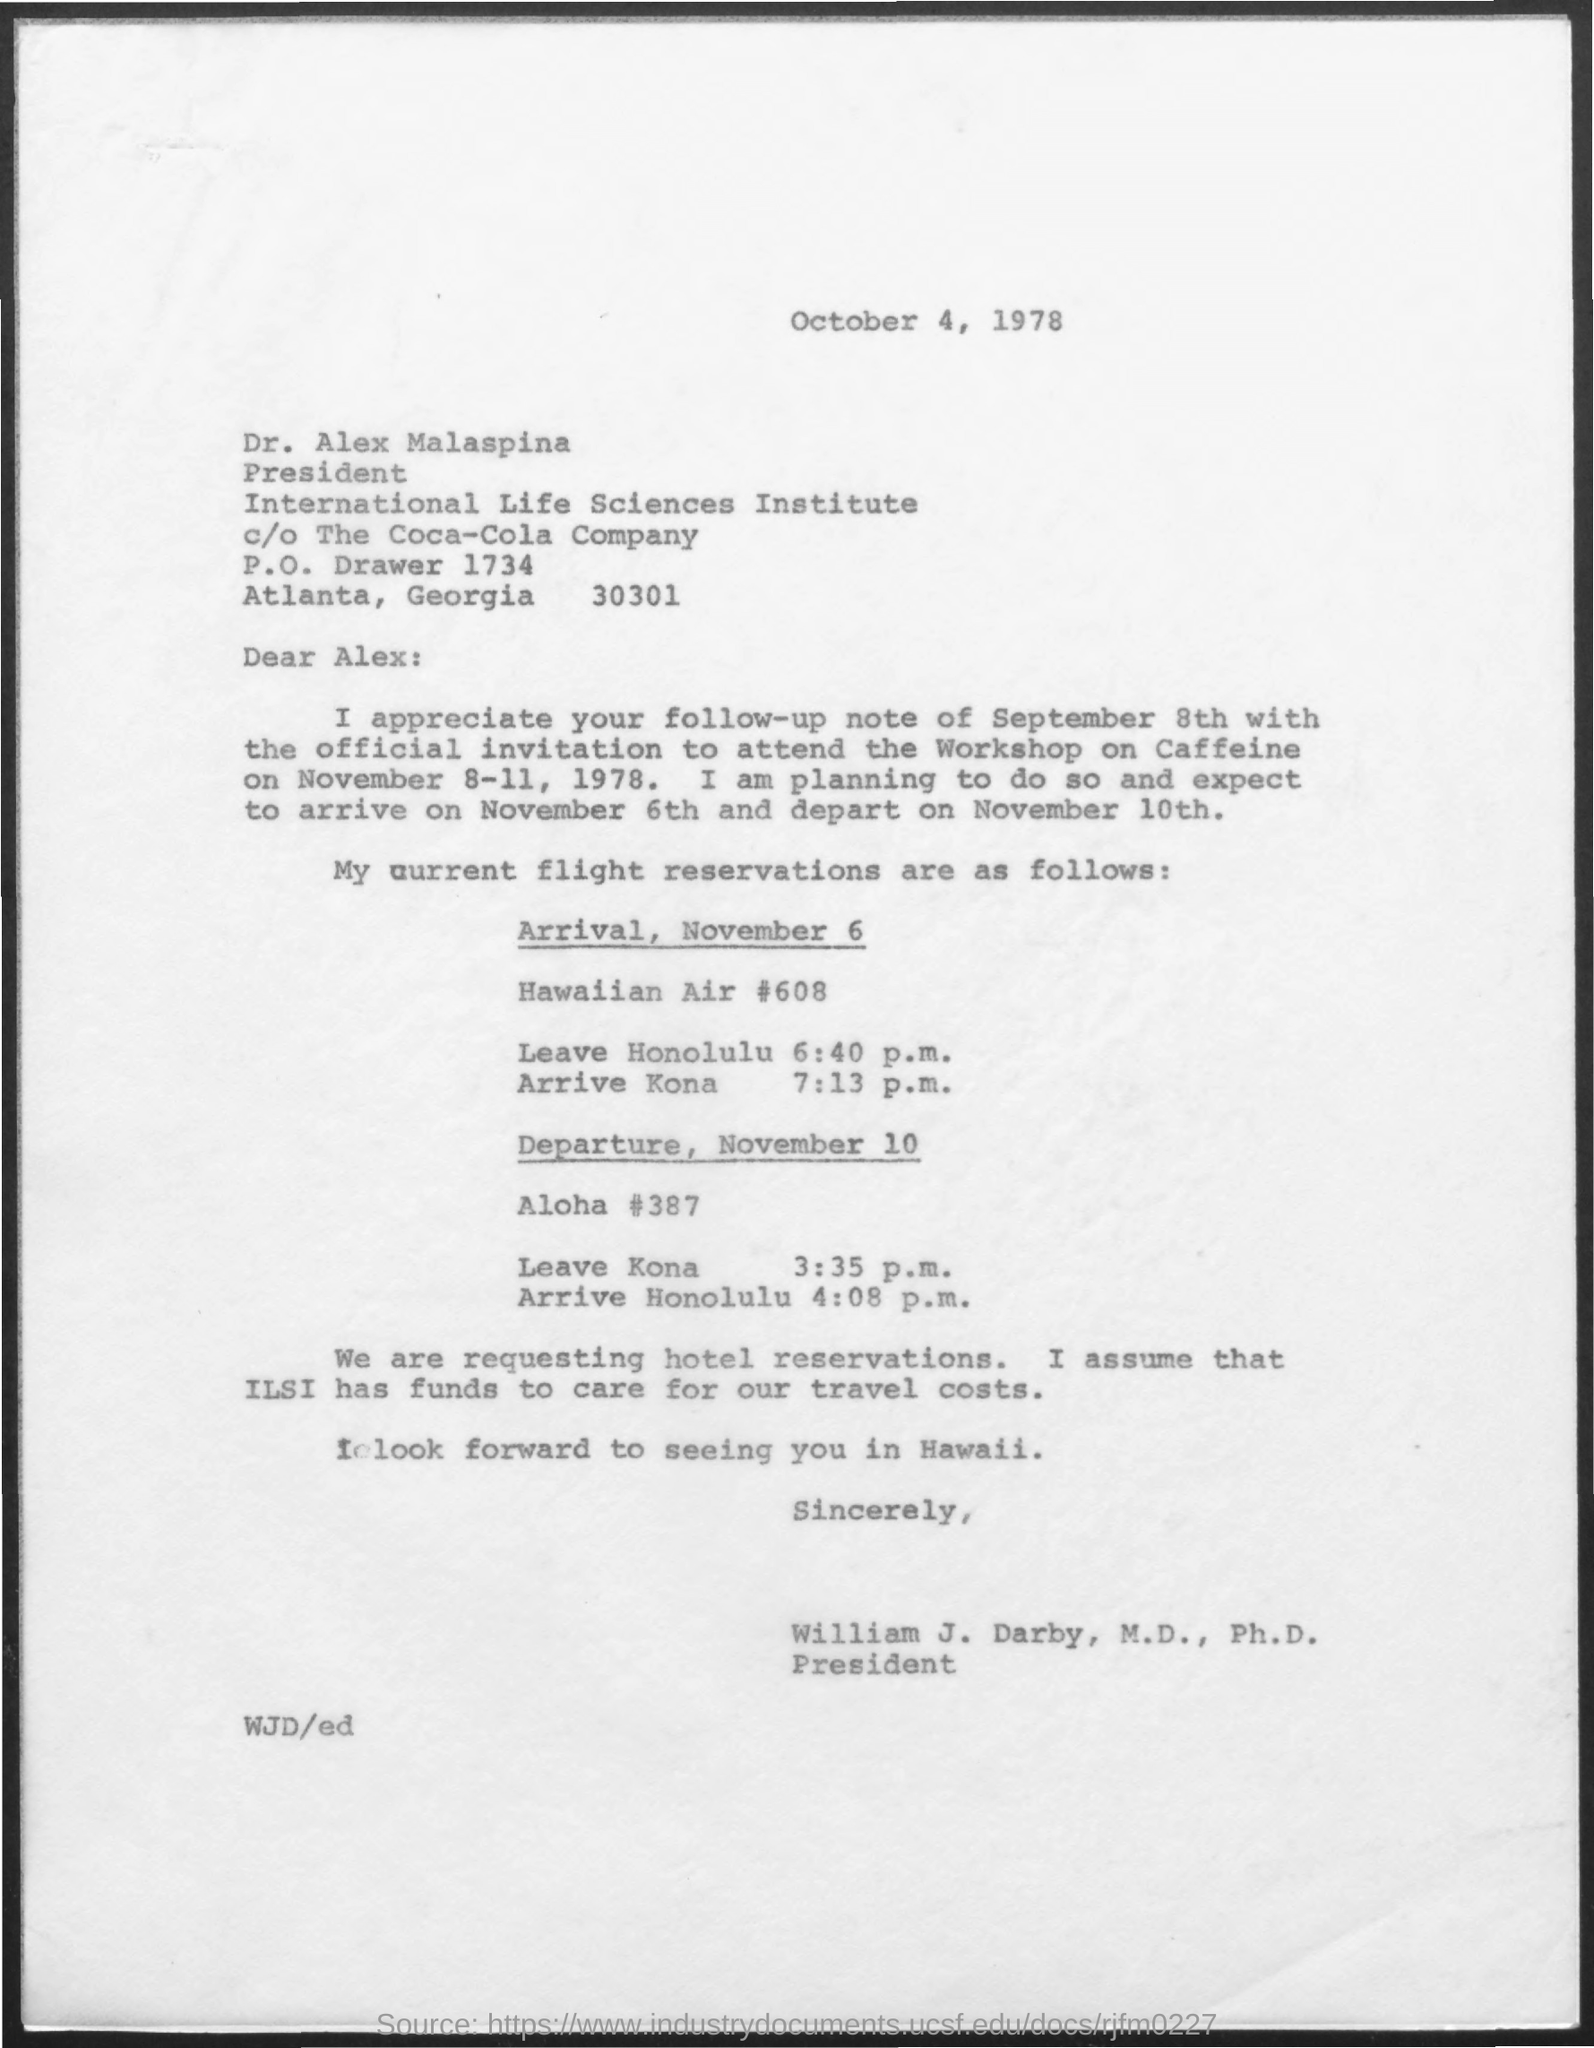Outline some significant characteristics in this image. The president of the International Life Science Institute is Alex. 